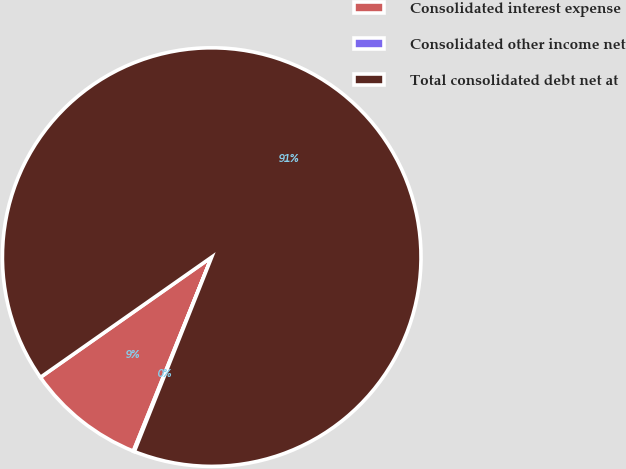Convert chart. <chart><loc_0><loc_0><loc_500><loc_500><pie_chart><fcel>Consolidated interest expense<fcel>Consolidated other income net<fcel>Total consolidated debt net at<nl><fcel>9.15%<fcel>0.08%<fcel>90.77%<nl></chart> 